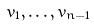Convert formula to latex. <formula><loc_0><loc_0><loc_500><loc_500>v _ { 1 } , \dots , v _ { n - 1 }</formula> 